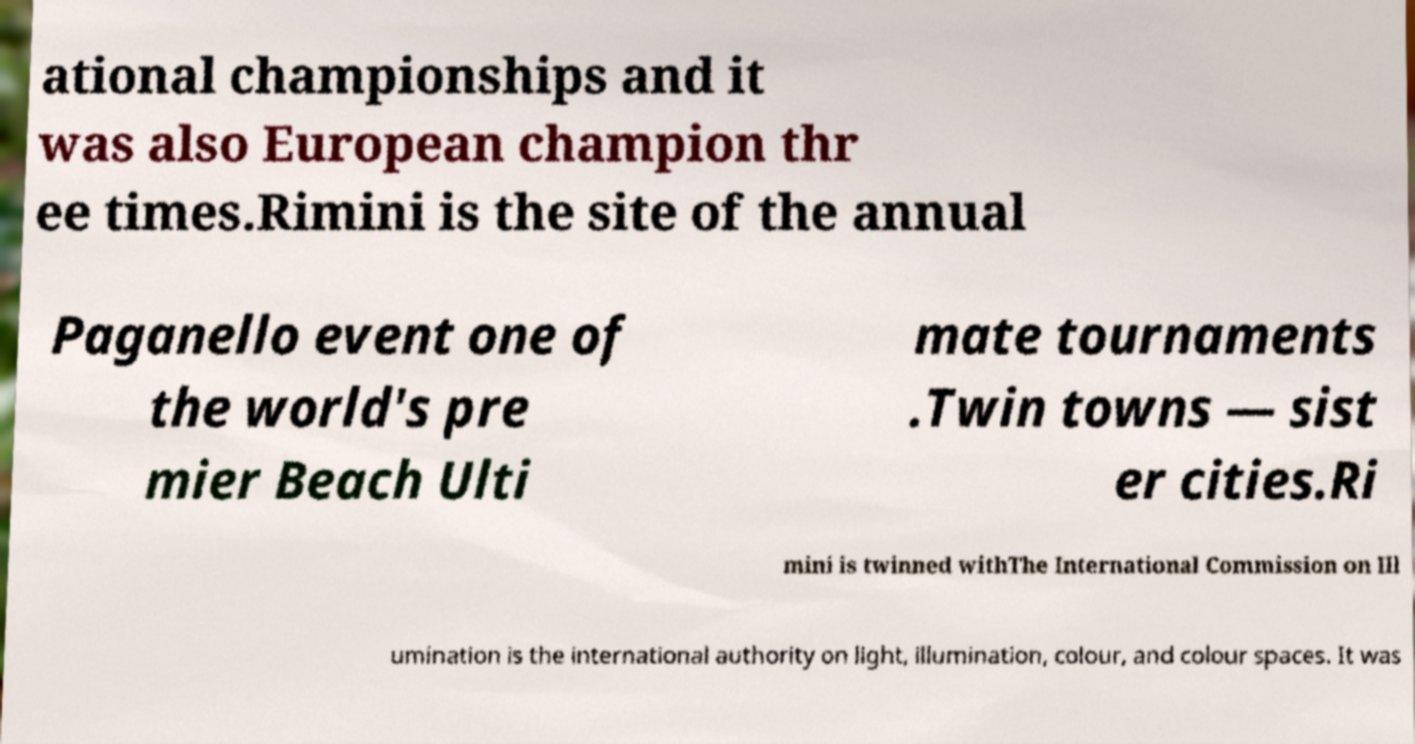I need the written content from this picture converted into text. Can you do that? ational championships and it was also European champion thr ee times.Rimini is the site of the annual Paganello event one of the world's pre mier Beach Ulti mate tournaments .Twin towns — sist er cities.Ri mini is twinned withThe International Commission on Ill umination is the international authority on light, illumination, colour, and colour spaces. It was 